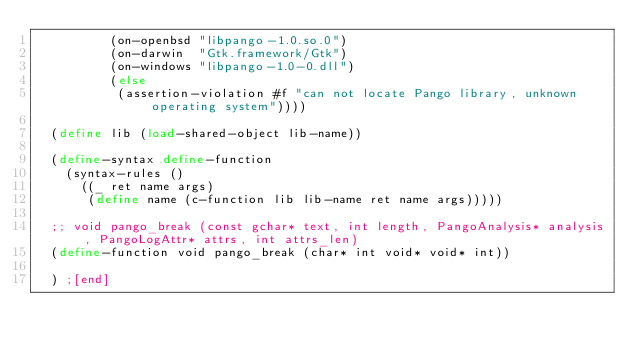<code> <loc_0><loc_0><loc_500><loc_500><_Scheme_>          (on-openbsd "libpango-1.0.so.0")
          (on-darwin  "Gtk.framework/Gtk")
          (on-windows "libpango-1.0-0.dll")
          (else
           (assertion-violation #f "can not locate Pango library, unknown operating system"))))

  (define lib (load-shared-object lib-name))

  (define-syntax define-function
    (syntax-rules ()
      ((_ ret name args)
       (define name (c-function lib lib-name ret name args)))))

  ;; void pango_break (const gchar* text, int length, PangoAnalysis* analysis, PangoLogAttr* attrs, int attrs_len)
  (define-function void pango_break (char* int void* void* int))

  ) ;[end]
</code> 